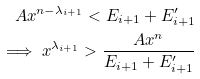<formula> <loc_0><loc_0><loc_500><loc_500>A x ^ { n - \lambda _ { i + 1 } } < E _ { i + 1 } + E _ { i + 1 } ^ { \prime } \\ \implies x ^ { \lambda _ { i + 1 } } > \frac { A x ^ { n } } { E _ { i + 1 } + E _ { i + 1 } ^ { \prime } }</formula> 